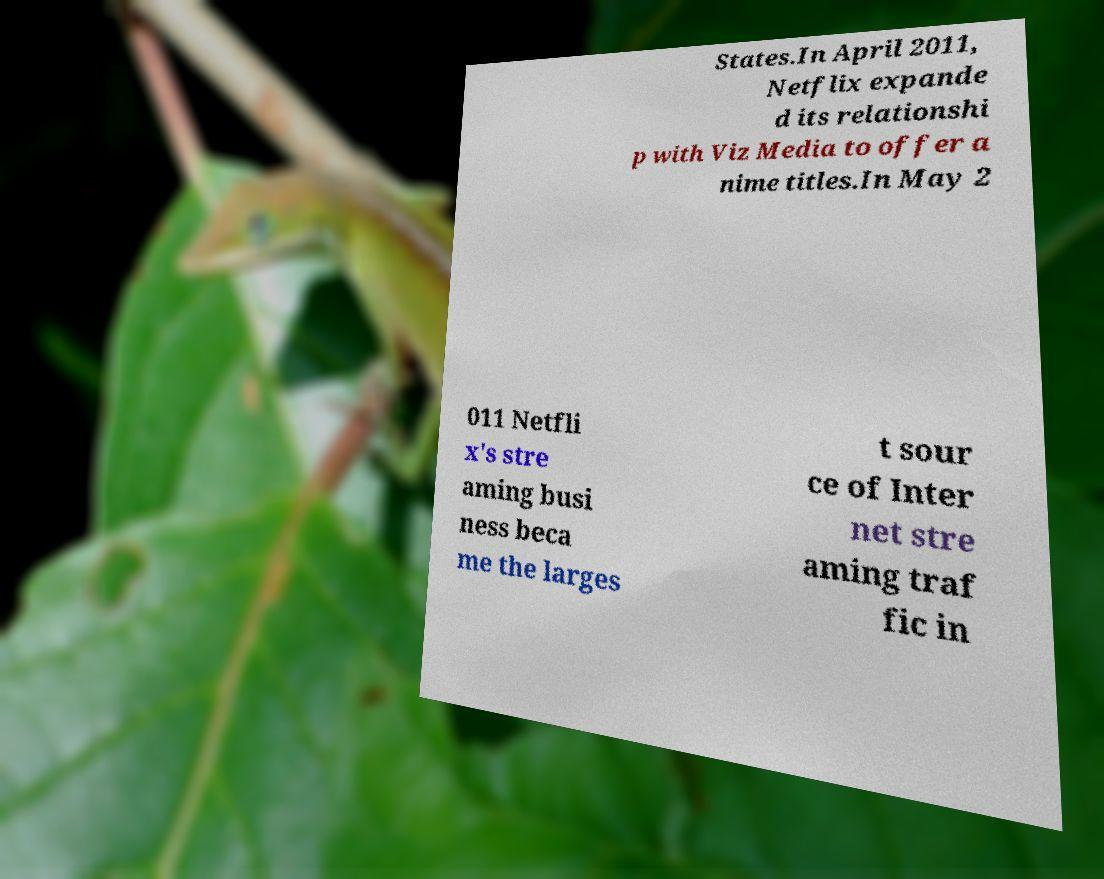Please read and relay the text visible in this image. What does it say? States.In April 2011, Netflix expande d its relationshi p with Viz Media to offer a nime titles.In May 2 011 Netfli x's stre aming busi ness beca me the larges t sour ce of Inter net stre aming traf fic in 